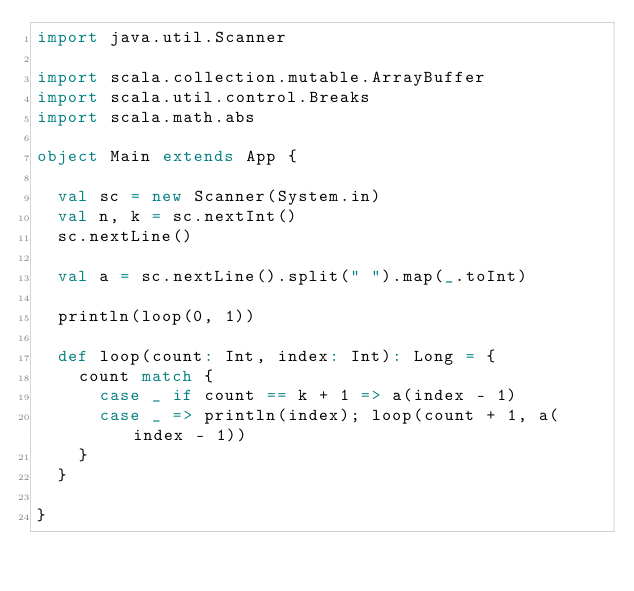<code> <loc_0><loc_0><loc_500><loc_500><_Scala_>import java.util.Scanner

import scala.collection.mutable.ArrayBuffer
import scala.util.control.Breaks
import scala.math.abs

object Main extends App {

  val sc = new Scanner(System.in)
  val n, k = sc.nextInt()
  sc.nextLine()

  val a = sc.nextLine().split(" ").map(_.toInt)

  println(loop(0, 1))

  def loop(count: Int, index: Int): Long = {
    count match {
      case _ if count == k + 1 => a(index - 1)
      case _ => println(index); loop(count + 1, a(index - 1))
    }
  }

}
</code> 